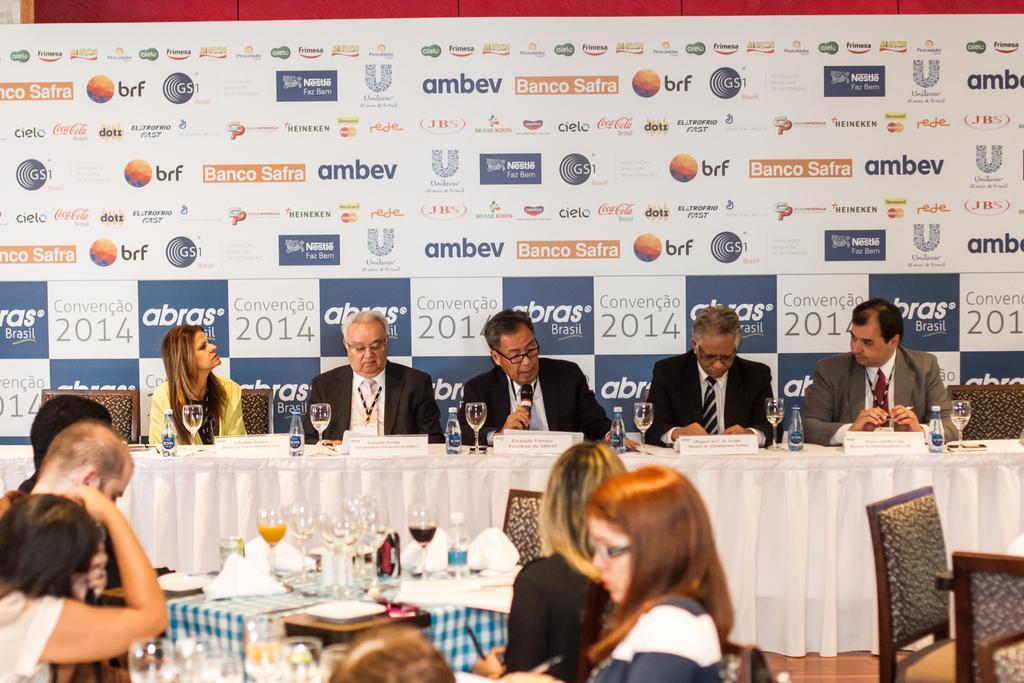How would you summarize this image in a sentence or two? This image consist of many people. To the front, there are five people sitting in front of table. The table is covered with white cloth on which there are glasses, bottles, and name plates. In the background, there is a banner. In the front, middle there is a table on which there are juice and glasses. There are many chairs in the image. 